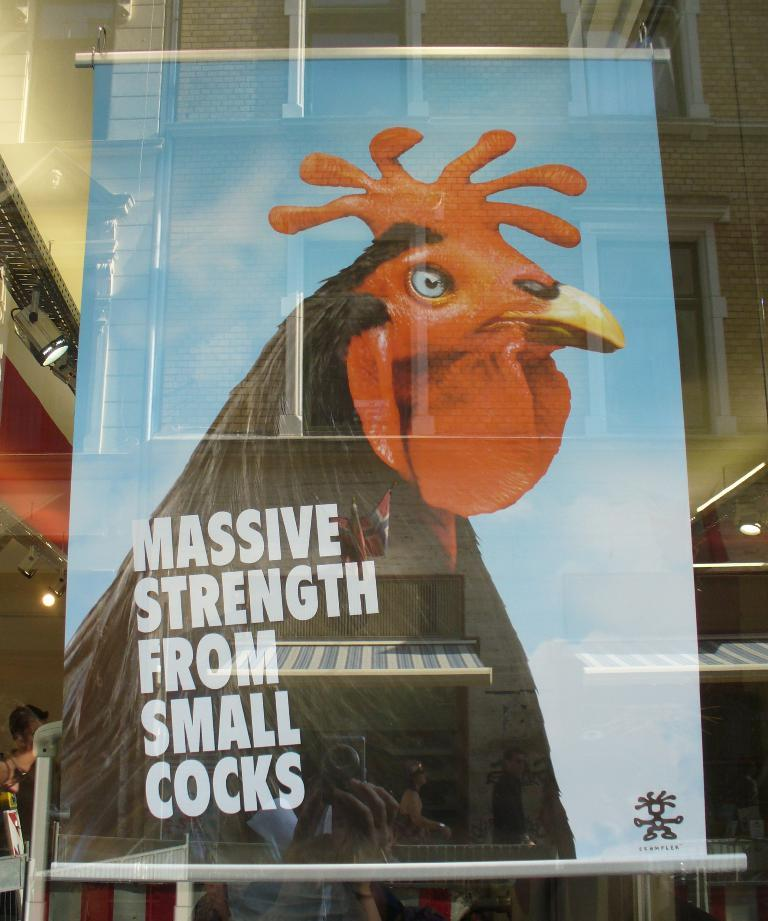What is hanging in the image? There is a banner hanging in the image. What is depicted on the banner? The banner contains a picture of a hen. What else can be seen on the banner besides the picture of the hen? There are letters on the banner. How was the image likely taken? The image appears to be taken through a glass door. What can be seen in the reflection on the glass door? The reflection of buildings and groups of people is visible on the glass door. Where is the zoo located in the image? There is no zoo present in the image; it features a banner with a picture of a hen. What type of fork is being used by the man in the image? There is no man or fork present in the image. 